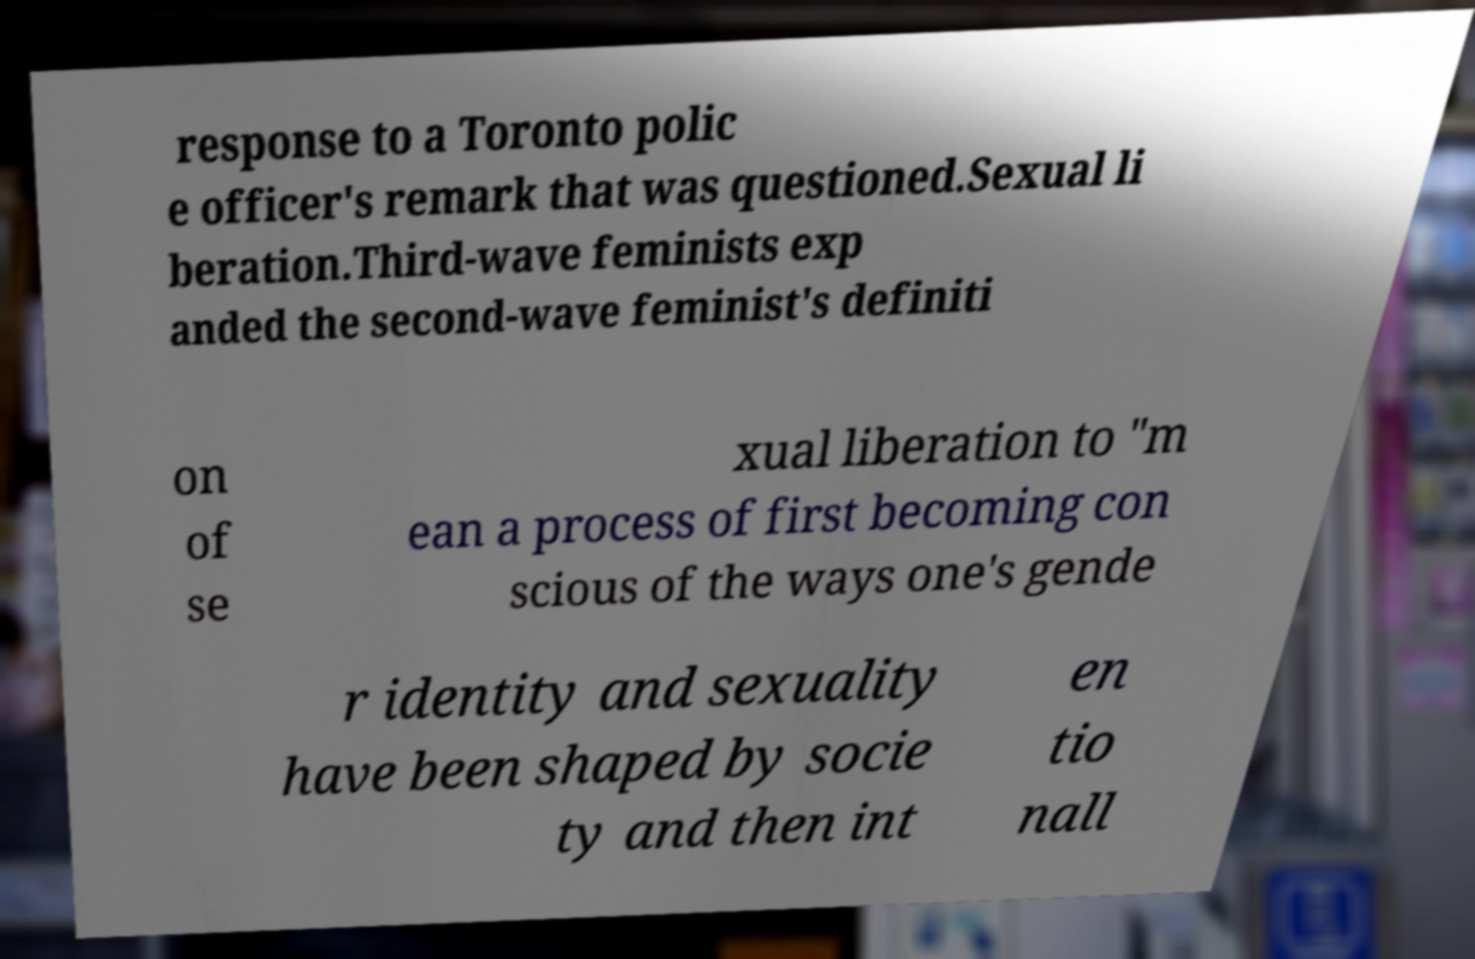I need the written content from this picture converted into text. Can you do that? response to a Toronto polic e officer's remark that was questioned.Sexual li beration.Third-wave feminists exp anded the second-wave feminist's definiti on of se xual liberation to "m ean a process of first becoming con scious of the ways one's gende r identity and sexuality have been shaped by socie ty and then int en tio nall 